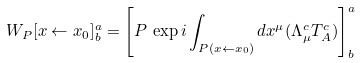<formula> <loc_0><loc_0><loc_500><loc_500>W _ { P } [ x \leftarrow x _ { 0 } ] ^ { a } _ { b } = \left [ P \, \exp i \int _ { P ( x \leftarrow x _ { 0 } ) } d x ^ { \mu } ( \Lambda _ { \mu } ^ { c } T _ { A } ^ { c } ) \right ] ^ { a } _ { b }</formula> 